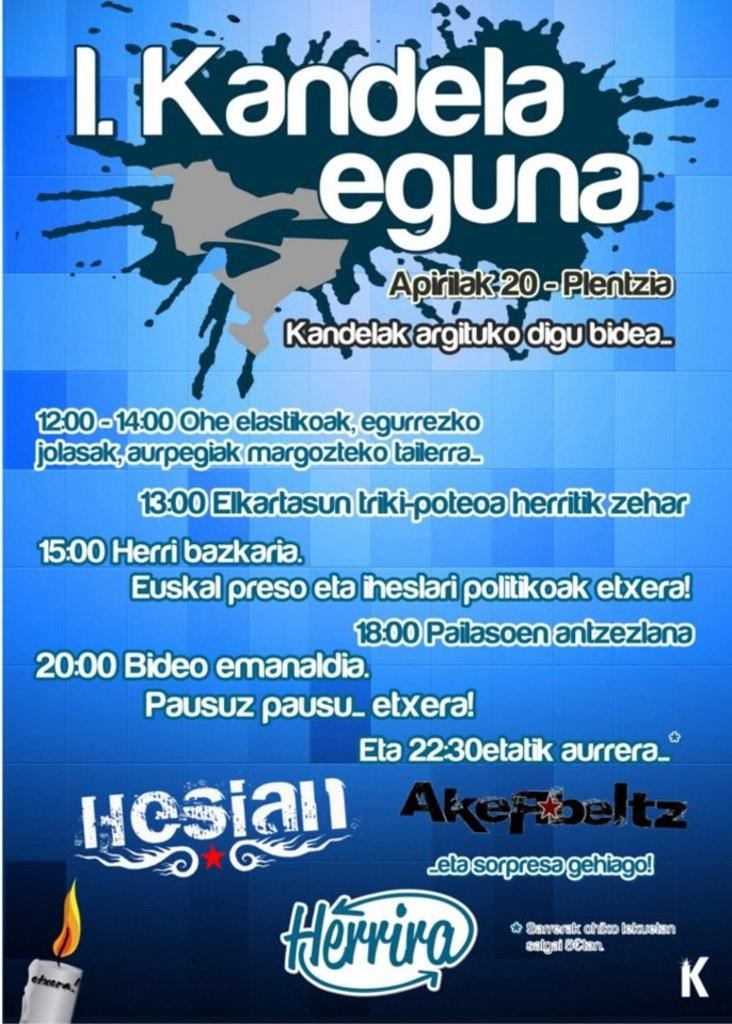What is featured on the poster in the image? The poster contains text and a logo. Can you describe the text on the poster? Unfortunately, the specific text on the poster cannot be determined from the provided facts. What other object is present in the image besides the poster? There is a candle in the image. How many parcels are being delivered by the flight in the image? There is no flight or parcel present in the image; it only features a poster and a candle. What type of string is used to hold the candle in place in the image? There is no mention of a string or any method of holding the candle in place in the provided facts. 